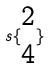<formula> <loc_0><loc_0><loc_500><loc_500>s \{ \begin{matrix} 2 \\ 4 \end{matrix} \}</formula> 